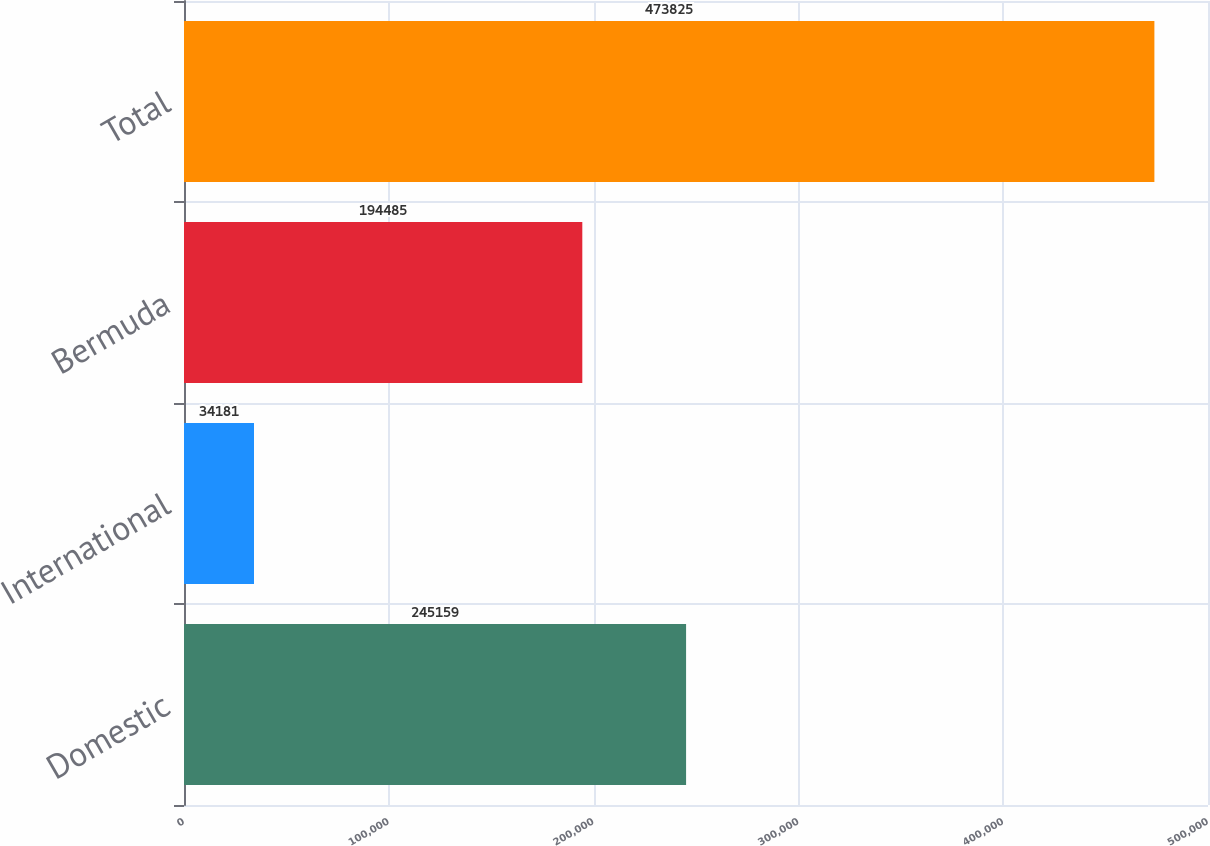Convert chart. <chart><loc_0><loc_0><loc_500><loc_500><bar_chart><fcel>Domestic<fcel>International<fcel>Bermuda<fcel>Total<nl><fcel>245159<fcel>34181<fcel>194485<fcel>473825<nl></chart> 